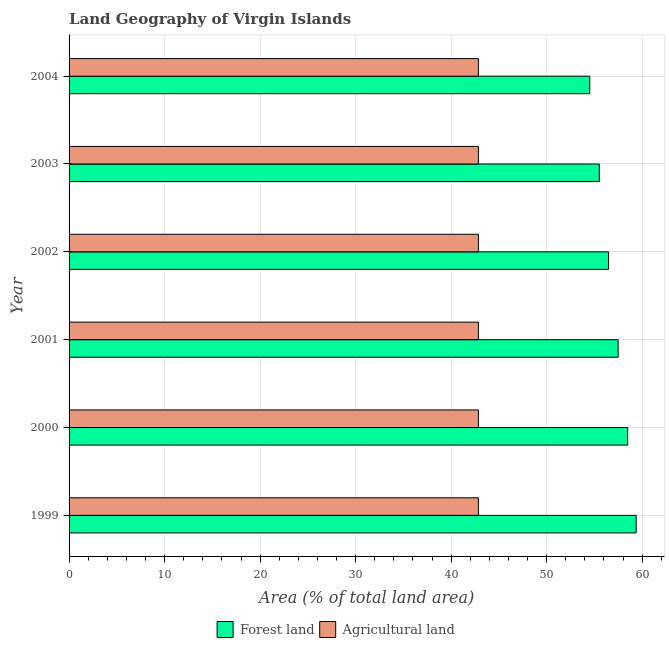How many groups of bars are there?
Provide a succinct answer. 6. Are the number of bars per tick equal to the number of legend labels?
Your answer should be very brief. Yes. In how many cases, is the number of bars for a given year not equal to the number of legend labels?
Your answer should be very brief. 0. What is the percentage of land area under forests in 2003?
Ensure brevity in your answer.  55.51. Across all years, what is the maximum percentage of land area under forests?
Make the answer very short. 59.37. Across all years, what is the minimum percentage of land area under forests?
Make the answer very short. 54.51. In which year was the percentage of land area under forests minimum?
Ensure brevity in your answer.  2004. What is the total percentage of land area under agriculture in the graph?
Provide a short and direct response. 257.14. What is the difference between the percentage of land area under agriculture in 2000 and the percentage of land area under forests in 2002?
Provide a succinct answer. -13.63. What is the average percentage of land area under forests per year?
Offer a terse response. 56.98. In the year 2001, what is the difference between the percentage of land area under agriculture and percentage of land area under forests?
Keep it short and to the point. -14.63. In how many years, is the percentage of land area under forests greater than 22 %?
Make the answer very short. 6. What is the ratio of the percentage of land area under agriculture in 2001 to that in 2004?
Your response must be concise. 1. What is the difference between the highest and the lowest percentage of land area under forests?
Offer a very short reply. 4.86. Is the sum of the percentage of land area under forests in 1999 and 2004 greater than the maximum percentage of land area under agriculture across all years?
Provide a succinct answer. Yes. What does the 2nd bar from the top in 2004 represents?
Offer a very short reply. Forest land. What does the 2nd bar from the bottom in 2004 represents?
Provide a short and direct response. Agricultural land. What is the difference between two consecutive major ticks on the X-axis?
Give a very brief answer. 10. Does the graph contain any zero values?
Offer a very short reply. No. How many legend labels are there?
Provide a succinct answer. 2. What is the title of the graph?
Provide a succinct answer. Land Geography of Virgin Islands. Does "Exports" appear as one of the legend labels in the graph?
Ensure brevity in your answer.  No. What is the label or title of the X-axis?
Ensure brevity in your answer.  Area (% of total land area). What is the Area (% of total land area) in Forest land in 1999?
Ensure brevity in your answer.  59.37. What is the Area (% of total land area) in Agricultural land in 1999?
Your answer should be compact. 42.86. What is the Area (% of total land area) of Forest land in 2000?
Your answer should be compact. 58.49. What is the Area (% of total land area) of Agricultural land in 2000?
Keep it short and to the point. 42.86. What is the Area (% of total land area) in Forest land in 2001?
Offer a terse response. 57.49. What is the Area (% of total land area) of Agricultural land in 2001?
Ensure brevity in your answer.  42.86. What is the Area (% of total land area) in Forest land in 2002?
Make the answer very short. 56.49. What is the Area (% of total land area) of Agricultural land in 2002?
Offer a very short reply. 42.86. What is the Area (% of total land area) in Forest land in 2003?
Your answer should be very brief. 55.51. What is the Area (% of total land area) in Agricultural land in 2003?
Provide a succinct answer. 42.86. What is the Area (% of total land area) of Forest land in 2004?
Ensure brevity in your answer.  54.51. What is the Area (% of total land area) in Agricultural land in 2004?
Offer a very short reply. 42.86. Across all years, what is the maximum Area (% of total land area) of Forest land?
Give a very brief answer. 59.37. Across all years, what is the maximum Area (% of total land area) of Agricultural land?
Provide a succinct answer. 42.86. Across all years, what is the minimum Area (% of total land area) in Forest land?
Your answer should be compact. 54.51. Across all years, what is the minimum Area (% of total land area) in Agricultural land?
Provide a succinct answer. 42.86. What is the total Area (% of total land area) of Forest land in the graph?
Your response must be concise. 341.86. What is the total Area (% of total land area) of Agricultural land in the graph?
Provide a succinct answer. 257.14. What is the difference between the Area (% of total land area) of Forest land in 1999 and that in 2000?
Your answer should be very brief. 0.89. What is the difference between the Area (% of total land area) of Agricultural land in 1999 and that in 2000?
Ensure brevity in your answer.  0. What is the difference between the Area (% of total land area) of Forest land in 1999 and that in 2001?
Your answer should be compact. 1.89. What is the difference between the Area (% of total land area) of Forest land in 1999 and that in 2002?
Keep it short and to the point. 2.89. What is the difference between the Area (% of total land area) of Agricultural land in 1999 and that in 2002?
Give a very brief answer. 0. What is the difference between the Area (% of total land area) in Forest land in 1999 and that in 2003?
Offer a very short reply. 3.86. What is the difference between the Area (% of total land area) in Agricultural land in 1999 and that in 2003?
Your answer should be very brief. 0. What is the difference between the Area (% of total land area) of Forest land in 1999 and that in 2004?
Make the answer very short. 4.86. What is the difference between the Area (% of total land area) in Forest land in 2000 and that in 2001?
Give a very brief answer. 1. What is the difference between the Area (% of total land area) of Agricultural land in 2000 and that in 2002?
Make the answer very short. 0. What is the difference between the Area (% of total land area) in Forest land in 2000 and that in 2003?
Your response must be concise. 2.97. What is the difference between the Area (% of total land area) in Agricultural land in 2000 and that in 2003?
Your answer should be compact. 0. What is the difference between the Area (% of total land area) in Forest land in 2000 and that in 2004?
Make the answer very short. 3.97. What is the difference between the Area (% of total land area) in Forest land in 2001 and that in 2002?
Ensure brevity in your answer.  1. What is the difference between the Area (% of total land area) in Forest land in 2001 and that in 2003?
Give a very brief answer. 1.97. What is the difference between the Area (% of total land area) of Forest land in 2001 and that in 2004?
Offer a terse response. 2.97. What is the difference between the Area (% of total land area) of Agricultural land in 2001 and that in 2004?
Offer a terse response. 0. What is the difference between the Area (% of total land area) of Forest land in 2002 and that in 2003?
Provide a short and direct response. 0.97. What is the difference between the Area (% of total land area) of Agricultural land in 2002 and that in 2003?
Ensure brevity in your answer.  0. What is the difference between the Area (% of total land area) of Forest land in 2002 and that in 2004?
Offer a very short reply. 1.97. What is the difference between the Area (% of total land area) in Forest land in 2003 and that in 2004?
Your answer should be compact. 1. What is the difference between the Area (% of total land area) in Forest land in 1999 and the Area (% of total land area) in Agricultural land in 2000?
Provide a succinct answer. 16.51. What is the difference between the Area (% of total land area) in Forest land in 1999 and the Area (% of total land area) in Agricultural land in 2001?
Keep it short and to the point. 16.51. What is the difference between the Area (% of total land area) in Forest land in 1999 and the Area (% of total land area) in Agricultural land in 2002?
Offer a very short reply. 16.51. What is the difference between the Area (% of total land area) in Forest land in 1999 and the Area (% of total land area) in Agricultural land in 2003?
Ensure brevity in your answer.  16.51. What is the difference between the Area (% of total land area) of Forest land in 1999 and the Area (% of total land area) of Agricultural land in 2004?
Provide a short and direct response. 16.51. What is the difference between the Area (% of total land area) of Forest land in 2000 and the Area (% of total land area) of Agricultural land in 2001?
Provide a succinct answer. 15.63. What is the difference between the Area (% of total land area) in Forest land in 2000 and the Area (% of total land area) in Agricultural land in 2002?
Make the answer very short. 15.63. What is the difference between the Area (% of total land area) in Forest land in 2000 and the Area (% of total land area) in Agricultural land in 2003?
Offer a terse response. 15.63. What is the difference between the Area (% of total land area) of Forest land in 2000 and the Area (% of total land area) of Agricultural land in 2004?
Your answer should be compact. 15.63. What is the difference between the Area (% of total land area) of Forest land in 2001 and the Area (% of total land area) of Agricultural land in 2002?
Offer a terse response. 14.63. What is the difference between the Area (% of total land area) in Forest land in 2001 and the Area (% of total land area) in Agricultural land in 2003?
Give a very brief answer. 14.63. What is the difference between the Area (% of total land area) of Forest land in 2001 and the Area (% of total land area) of Agricultural land in 2004?
Make the answer very short. 14.63. What is the difference between the Area (% of total land area) of Forest land in 2002 and the Area (% of total land area) of Agricultural land in 2003?
Your answer should be compact. 13.63. What is the difference between the Area (% of total land area) in Forest land in 2002 and the Area (% of total land area) in Agricultural land in 2004?
Ensure brevity in your answer.  13.63. What is the difference between the Area (% of total land area) in Forest land in 2003 and the Area (% of total land area) in Agricultural land in 2004?
Keep it short and to the point. 12.66. What is the average Area (% of total land area) in Forest land per year?
Keep it short and to the point. 56.98. What is the average Area (% of total land area) in Agricultural land per year?
Your response must be concise. 42.86. In the year 1999, what is the difference between the Area (% of total land area) of Forest land and Area (% of total land area) of Agricultural land?
Provide a short and direct response. 16.51. In the year 2000, what is the difference between the Area (% of total land area) of Forest land and Area (% of total land area) of Agricultural land?
Make the answer very short. 15.63. In the year 2001, what is the difference between the Area (% of total land area) of Forest land and Area (% of total land area) of Agricultural land?
Your answer should be compact. 14.63. In the year 2002, what is the difference between the Area (% of total land area) in Forest land and Area (% of total land area) in Agricultural land?
Your answer should be compact. 13.63. In the year 2003, what is the difference between the Area (% of total land area) of Forest land and Area (% of total land area) of Agricultural land?
Your answer should be very brief. 12.66. In the year 2004, what is the difference between the Area (% of total land area) of Forest land and Area (% of total land area) of Agricultural land?
Offer a terse response. 11.66. What is the ratio of the Area (% of total land area) of Forest land in 1999 to that in 2000?
Your response must be concise. 1.02. What is the ratio of the Area (% of total land area) of Agricultural land in 1999 to that in 2000?
Ensure brevity in your answer.  1. What is the ratio of the Area (% of total land area) in Forest land in 1999 to that in 2001?
Offer a very short reply. 1.03. What is the ratio of the Area (% of total land area) of Forest land in 1999 to that in 2002?
Offer a terse response. 1.05. What is the ratio of the Area (% of total land area) of Forest land in 1999 to that in 2003?
Give a very brief answer. 1.07. What is the ratio of the Area (% of total land area) in Forest land in 1999 to that in 2004?
Offer a terse response. 1.09. What is the ratio of the Area (% of total land area) of Forest land in 2000 to that in 2001?
Offer a terse response. 1.02. What is the ratio of the Area (% of total land area) in Agricultural land in 2000 to that in 2001?
Ensure brevity in your answer.  1. What is the ratio of the Area (% of total land area) in Forest land in 2000 to that in 2002?
Provide a short and direct response. 1.04. What is the ratio of the Area (% of total land area) in Forest land in 2000 to that in 2003?
Offer a terse response. 1.05. What is the ratio of the Area (% of total land area) in Agricultural land in 2000 to that in 2003?
Offer a very short reply. 1. What is the ratio of the Area (% of total land area) in Forest land in 2000 to that in 2004?
Your response must be concise. 1.07. What is the ratio of the Area (% of total land area) of Forest land in 2001 to that in 2002?
Make the answer very short. 1.02. What is the ratio of the Area (% of total land area) in Agricultural land in 2001 to that in 2002?
Provide a succinct answer. 1. What is the ratio of the Area (% of total land area) in Forest land in 2001 to that in 2003?
Your answer should be very brief. 1.04. What is the ratio of the Area (% of total land area) in Agricultural land in 2001 to that in 2003?
Make the answer very short. 1. What is the ratio of the Area (% of total land area) in Forest land in 2001 to that in 2004?
Ensure brevity in your answer.  1.05. What is the ratio of the Area (% of total land area) of Forest land in 2002 to that in 2003?
Offer a terse response. 1.02. What is the ratio of the Area (% of total land area) in Agricultural land in 2002 to that in 2003?
Your response must be concise. 1. What is the ratio of the Area (% of total land area) of Forest land in 2002 to that in 2004?
Your answer should be very brief. 1.04. What is the ratio of the Area (% of total land area) of Forest land in 2003 to that in 2004?
Provide a short and direct response. 1.02. What is the difference between the highest and the second highest Area (% of total land area) in Forest land?
Provide a short and direct response. 0.89. What is the difference between the highest and the lowest Area (% of total land area) of Forest land?
Your answer should be compact. 4.86. What is the difference between the highest and the lowest Area (% of total land area) of Agricultural land?
Offer a terse response. 0. 